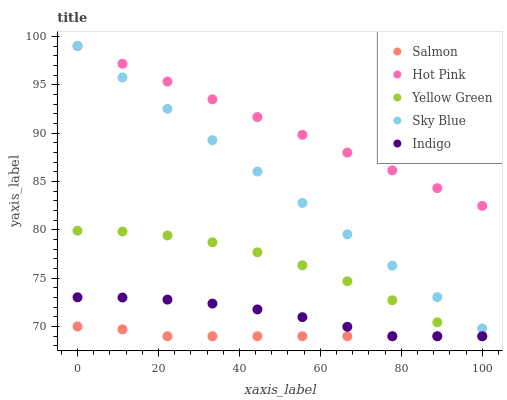Does Salmon have the minimum area under the curve?
Answer yes or no. Yes. Does Hot Pink have the maximum area under the curve?
Answer yes or no. Yes. Does Hot Pink have the minimum area under the curve?
Answer yes or no. No. Does Salmon have the maximum area under the curve?
Answer yes or no. No. Is Hot Pink the smoothest?
Answer yes or no. Yes. Is Yellow Green the roughest?
Answer yes or no. Yes. Is Salmon the smoothest?
Answer yes or no. No. Is Salmon the roughest?
Answer yes or no. No. Does Salmon have the lowest value?
Answer yes or no. Yes. Does Hot Pink have the lowest value?
Answer yes or no. No. Does Hot Pink have the highest value?
Answer yes or no. Yes. Does Salmon have the highest value?
Answer yes or no. No. Is Indigo less than Sky Blue?
Answer yes or no. Yes. Is Sky Blue greater than Indigo?
Answer yes or no. Yes. Does Sky Blue intersect Hot Pink?
Answer yes or no. Yes. Is Sky Blue less than Hot Pink?
Answer yes or no. No. Is Sky Blue greater than Hot Pink?
Answer yes or no. No. Does Indigo intersect Sky Blue?
Answer yes or no. No. 